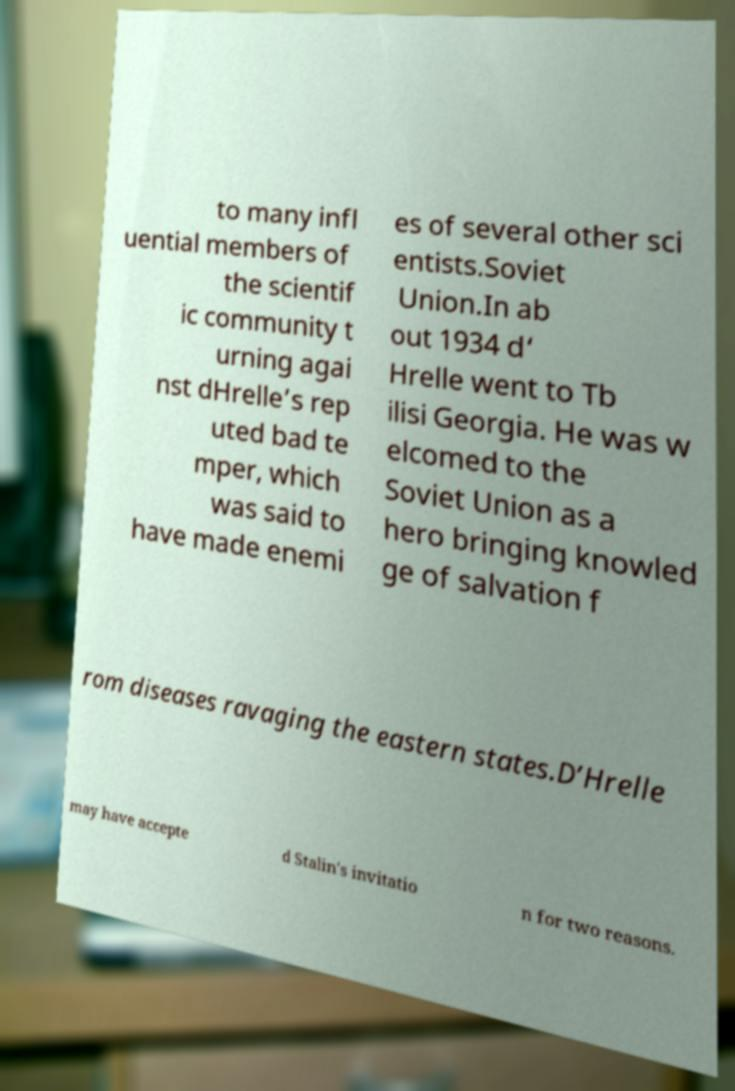What messages or text are displayed in this image? I need them in a readable, typed format. to many infl uential members of the scientif ic community t urning agai nst dHrelle’s rep uted bad te mper, which was said to have made enemi es of several other sci entists.Soviet Union.In ab out 1934 d‘ Hrelle went to Tb ilisi Georgia. He was w elcomed to the Soviet Union as a hero bringing knowled ge of salvation f rom diseases ravaging the eastern states.D’Hrelle may have accepte d Stalin's invitatio n for two reasons. 